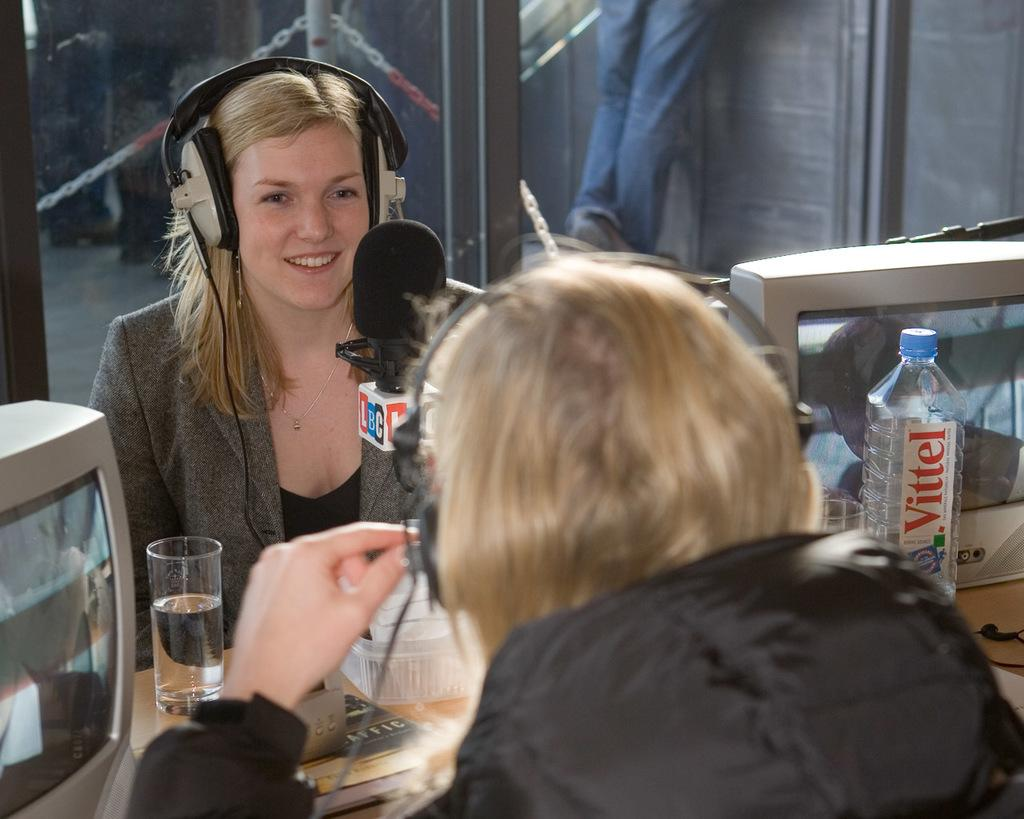How many people are sitting in the image? There are two people sitting in the image. What is present between the two people? There is a microphone between the two people. Can you describe the girl's appearance in the image? The girl is wearing headphones in the image. How many trees can be seen in the image? There are no trees visible in the image. What type of net is being used by the girl in the image? There is no net present in the image. 